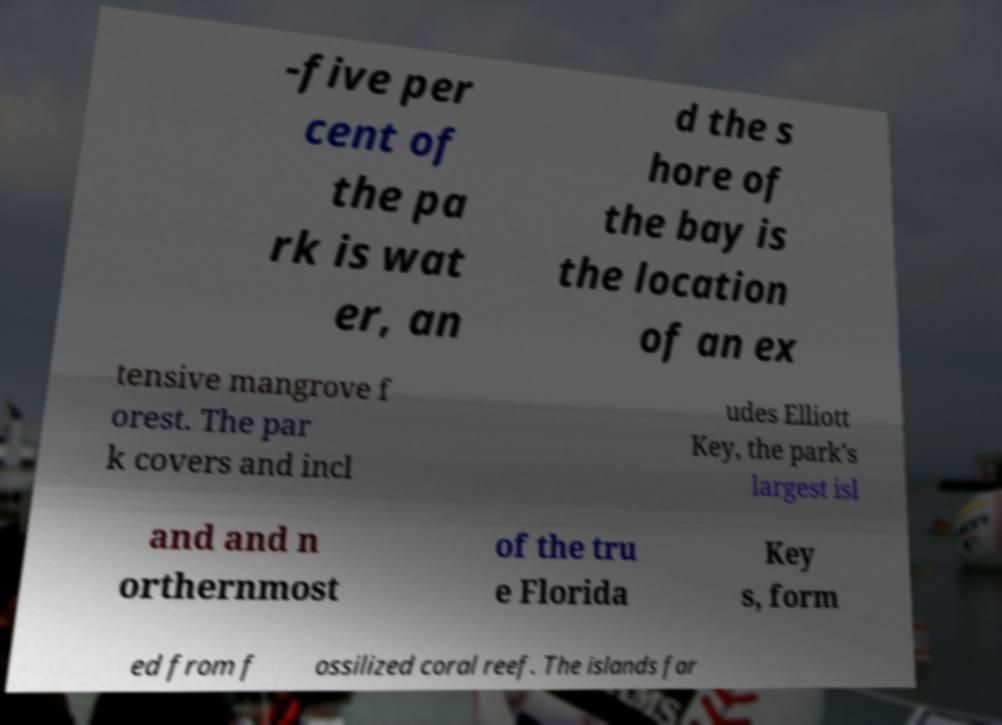Please read and relay the text visible in this image. What does it say? -five per cent of the pa rk is wat er, an d the s hore of the bay is the location of an ex tensive mangrove f orest. The par k covers and incl udes Elliott Key, the park's largest isl and and n orthernmost of the tru e Florida Key s, form ed from f ossilized coral reef. The islands far 